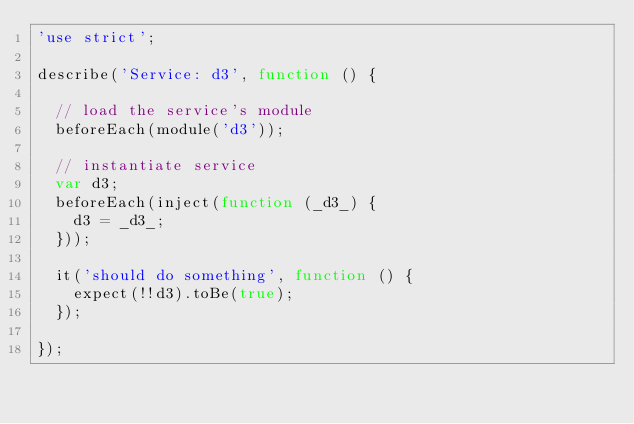Convert code to text. <code><loc_0><loc_0><loc_500><loc_500><_JavaScript_>'use strict';

describe('Service: d3', function () {

  // load the service's module
  beforeEach(module('d3'));

  // instantiate service
  var d3;
  beforeEach(inject(function (_d3_) {
    d3 = _d3_;
  }));

  it('should do something', function () {
    expect(!!d3).toBe(true);
  });

});
</code> 